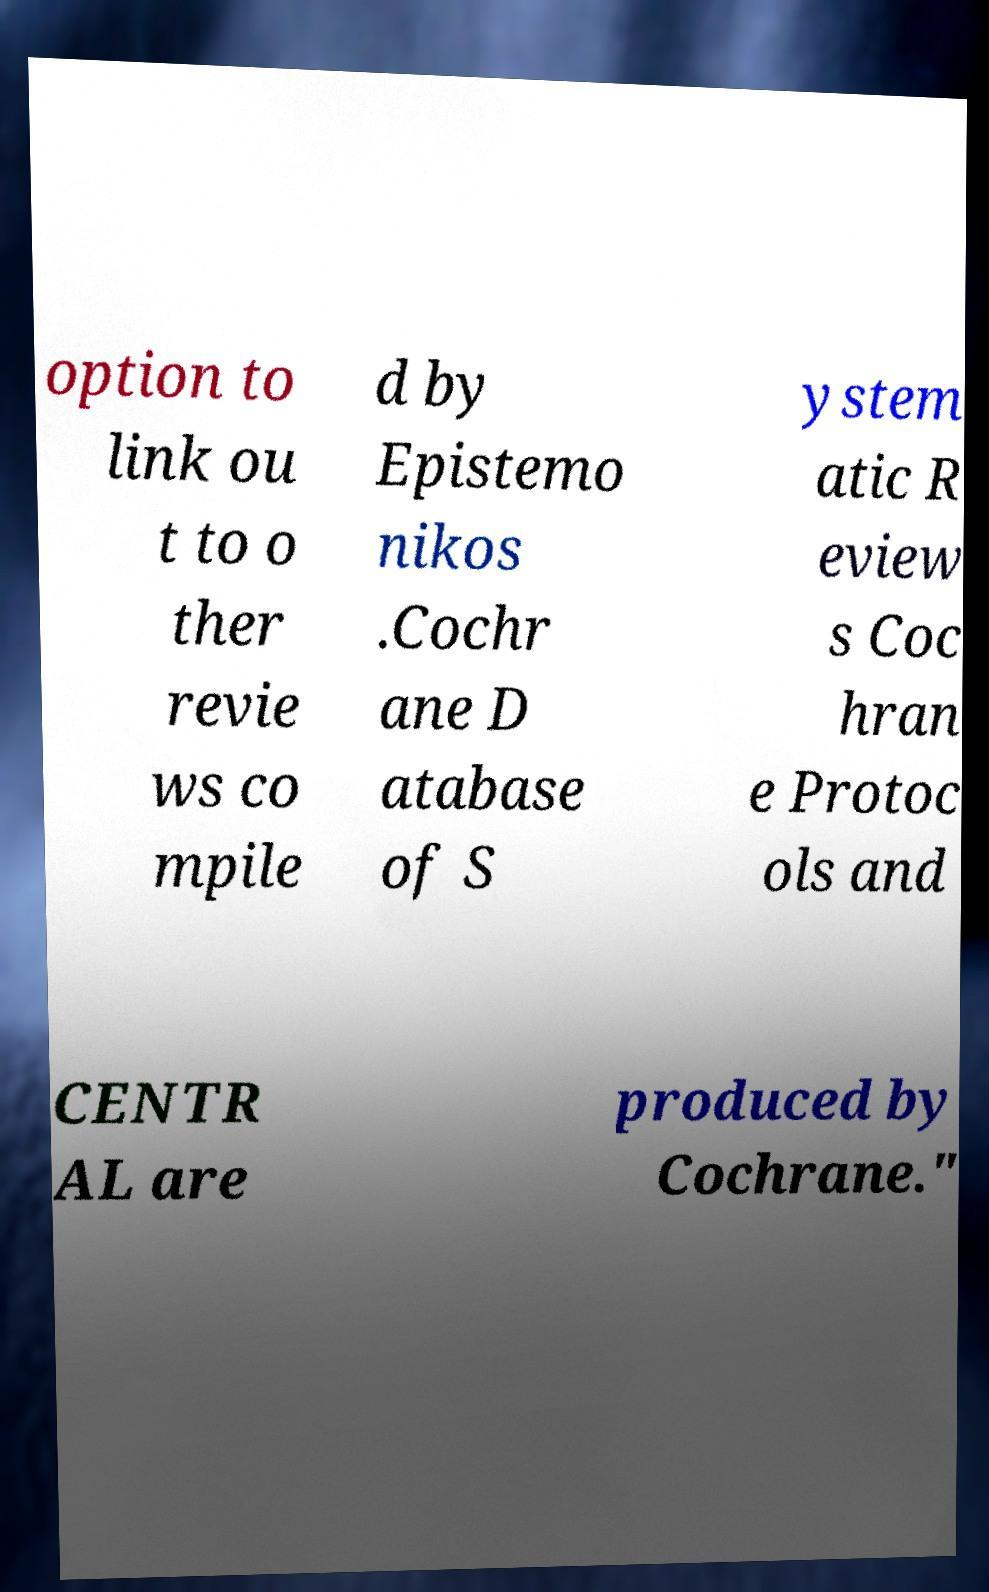Can you accurately transcribe the text from the provided image for me? option to link ou t to o ther revie ws co mpile d by Epistemo nikos .Cochr ane D atabase of S ystem atic R eview s Coc hran e Protoc ols and CENTR AL are produced by Cochrane." 